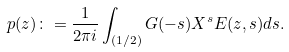Convert formula to latex. <formula><loc_0><loc_0><loc_500><loc_500>p ( z ) \colon = \frac { 1 } { 2 \pi i } \int _ { ( 1 / 2 ) } G ( - s ) X ^ { s } E ( z , s ) d s .</formula> 